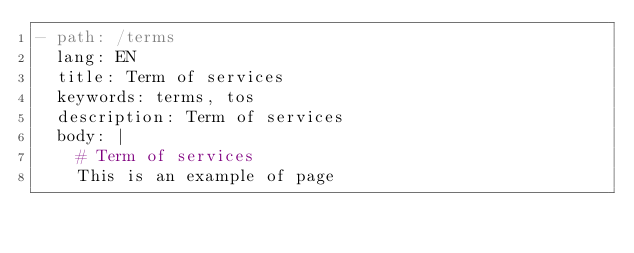<code> <loc_0><loc_0><loc_500><loc_500><_YAML_>- path: /terms
  lang: EN
  title: Term of services
  keywords: terms, tos
  description: Term of services
  body: |
    # Term of services
    This is an example of page</code> 